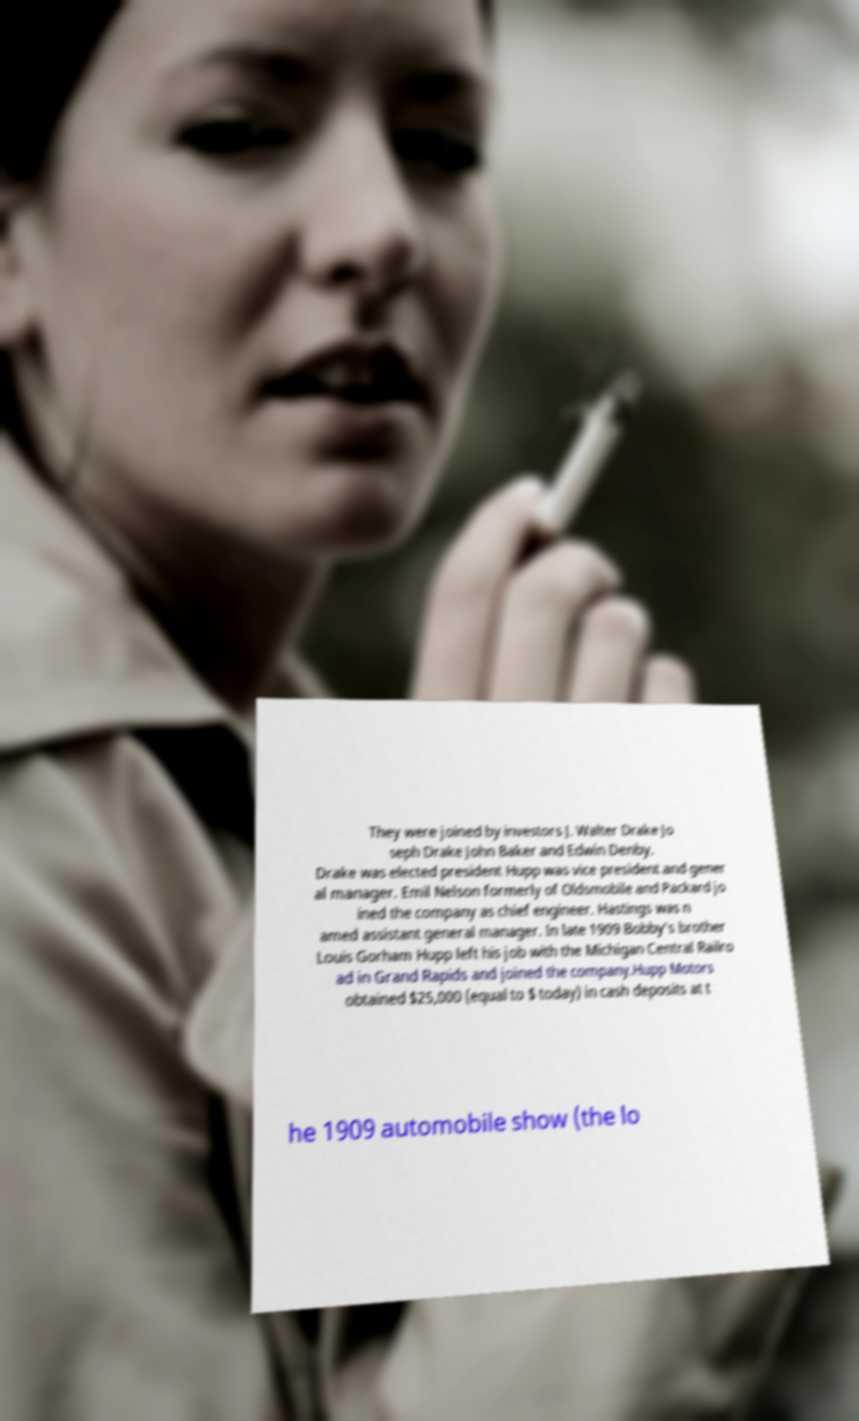Could you extract and type out the text from this image? They were joined by investors J. Walter Drake Jo seph Drake John Baker and Edwin Denby. Drake was elected president Hupp was vice president and gener al manager. Emil Nelson formerly of Oldsmobile and Packard jo ined the company as chief engineer. Hastings was n amed assistant general manager. In late 1909 Bobby's brother Louis Gorham Hupp left his job with the Michigan Central Railro ad in Grand Rapids and joined the company.Hupp Motors obtained $25,000 (equal to $ today) in cash deposits at t he 1909 automobile show (the lo 